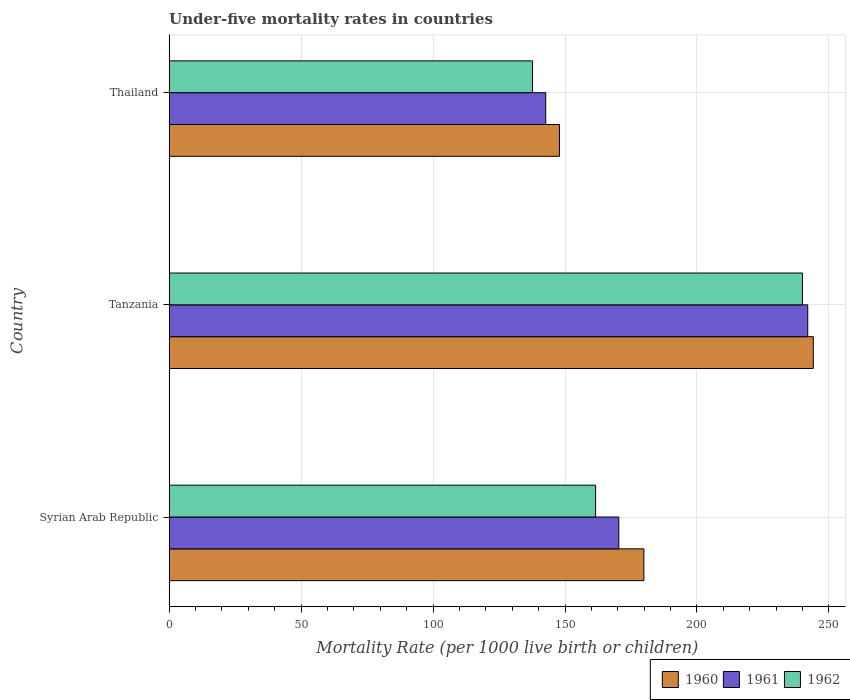Are the number of bars on each tick of the Y-axis equal?
Your answer should be very brief. Yes. How many bars are there on the 2nd tick from the top?
Offer a terse response. 3. How many bars are there on the 1st tick from the bottom?
Your answer should be very brief. 3. What is the label of the 2nd group of bars from the top?
Offer a very short reply. Tanzania. In how many cases, is the number of bars for a given country not equal to the number of legend labels?
Provide a succinct answer. 0. What is the under-five mortality rate in 1962 in Syrian Arab Republic?
Your answer should be compact. 161.6. Across all countries, what is the maximum under-five mortality rate in 1962?
Ensure brevity in your answer.  240. Across all countries, what is the minimum under-five mortality rate in 1962?
Make the answer very short. 137.7. In which country was the under-five mortality rate in 1961 maximum?
Provide a succinct answer. Tanzania. In which country was the under-five mortality rate in 1961 minimum?
Your answer should be compact. Thailand. What is the total under-five mortality rate in 1960 in the graph?
Your answer should be very brief. 571.9. What is the difference between the under-five mortality rate in 1962 in Thailand and the under-five mortality rate in 1961 in Tanzania?
Offer a terse response. -104.3. What is the average under-five mortality rate in 1961 per country?
Make the answer very short. 185.03. What is the difference between the under-five mortality rate in 1960 and under-five mortality rate in 1961 in Tanzania?
Provide a short and direct response. 2.1. What is the ratio of the under-five mortality rate in 1960 in Syrian Arab Republic to that in Thailand?
Your answer should be compact. 1.22. Is the difference between the under-five mortality rate in 1960 in Tanzania and Thailand greater than the difference between the under-five mortality rate in 1961 in Tanzania and Thailand?
Offer a terse response. No. What is the difference between the highest and the second highest under-five mortality rate in 1961?
Your response must be concise. 71.6. What is the difference between the highest and the lowest under-five mortality rate in 1960?
Your answer should be very brief. 96.2. Is the sum of the under-five mortality rate in 1962 in Syrian Arab Republic and Thailand greater than the maximum under-five mortality rate in 1960 across all countries?
Offer a very short reply. Yes. What does the 2nd bar from the top in Tanzania represents?
Your answer should be compact. 1961. Is it the case that in every country, the sum of the under-five mortality rate in 1960 and under-five mortality rate in 1962 is greater than the under-five mortality rate in 1961?
Make the answer very short. Yes. How many bars are there?
Give a very brief answer. 9. Are all the bars in the graph horizontal?
Provide a short and direct response. Yes. How many countries are there in the graph?
Give a very brief answer. 3. What is the difference between two consecutive major ticks on the X-axis?
Keep it short and to the point. 50. Does the graph contain grids?
Offer a terse response. Yes. Where does the legend appear in the graph?
Provide a short and direct response. Bottom right. How many legend labels are there?
Keep it short and to the point. 3. What is the title of the graph?
Your answer should be compact. Under-five mortality rates in countries. What is the label or title of the X-axis?
Your answer should be very brief. Mortality Rate (per 1000 live birth or children). What is the label or title of the Y-axis?
Your response must be concise. Country. What is the Mortality Rate (per 1000 live birth or children) of 1960 in Syrian Arab Republic?
Offer a terse response. 179.9. What is the Mortality Rate (per 1000 live birth or children) of 1961 in Syrian Arab Republic?
Make the answer very short. 170.4. What is the Mortality Rate (per 1000 live birth or children) of 1962 in Syrian Arab Republic?
Your answer should be compact. 161.6. What is the Mortality Rate (per 1000 live birth or children) of 1960 in Tanzania?
Your answer should be very brief. 244.1. What is the Mortality Rate (per 1000 live birth or children) of 1961 in Tanzania?
Ensure brevity in your answer.  242. What is the Mortality Rate (per 1000 live birth or children) in 1962 in Tanzania?
Offer a terse response. 240. What is the Mortality Rate (per 1000 live birth or children) of 1960 in Thailand?
Your response must be concise. 147.9. What is the Mortality Rate (per 1000 live birth or children) of 1961 in Thailand?
Offer a very short reply. 142.7. What is the Mortality Rate (per 1000 live birth or children) of 1962 in Thailand?
Offer a terse response. 137.7. Across all countries, what is the maximum Mortality Rate (per 1000 live birth or children) in 1960?
Your answer should be compact. 244.1. Across all countries, what is the maximum Mortality Rate (per 1000 live birth or children) in 1961?
Offer a terse response. 242. Across all countries, what is the maximum Mortality Rate (per 1000 live birth or children) in 1962?
Offer a very short reply. 240. Across all countries, what is the minimum Mortality Rate (per 1000 live birth or children) in 1960?
Ensure brevity in your answer.  147.9. Across all countries, what is the minimum Mortality Rate (per 1000 live birth or children) in 1961?
Ensure brevity in your answer.  142.7. Across all countries, what is the minimum Mortality Rate (per 1000 live birth or children) of 1962?
Provide a short and direct response. 137.7. What is the total Mortality Rate (per 1000 live birth or children) of 1960 in the graph?
Ensure brevity in your answer.  571.9. What is the total Mortality Rate (per 1000 live birth or children) in 1961 in the graph?
Your answer should be compact. 555.1. What is the total Mortality Rate (per 1000 live birth or children) in 1962 in the graph?
Your answer should be very brief. 539.3. What is the difference between the Mortality Rate (per 1000 live birth or children) of 1960 in Syrian Arab Republic and that in Tanzania?
Make the answer very short. -64.2. What is the difference between the Mortality Rate (per 1000 live birth or children) of 1961 in Syrian Arab Republic and that in Tanzania?
Give a very brief answer. -71.6. What is the difference between the Mortality Rate (per 1000 live birth or children) of 1962 in Syrian Arab Republic and that in Tanzania?
Give a very brief answer. -78.4. What is the difference between the Mortality Rate (per 1000 live birth or children) of 1961 in Syrian Arab Republic and that in Thailand?
Your response must be concise. 27.7. What is the difference between the Mortality Rate (per 1000 live birth or children) in 1962 in Syrian Arab Republic and that in Thailand?
Offer a very short reply. 23.9. What is the difference between the Mortality Rate (per 1000 live birth or children) of 1960 in Tanzania and that in Thailand?
Keep it short and to the point. 96.2. What is the difference between the Mortality Rate (per 1000 live birth or children) in 1961 in Tanzania and that in Thailand?
Your answer should be compact. 99.3. What is the difference between the Mortality Rate (per 1000 live birth or children) in 1962 in Tanzania and that in Thailand?
Provide a succinct answer. 102.3. What is the difference between the Mortality Rate (per 1000 live birth or children) in 1960 in Syrian Arab Republic and the Mortality Rate (per 1000 live birth or children) in 1961 in Tanzania?
Your response must be concise. -62.1. What is the difference between the Mortality Rate (per 1000 live birth or children) of 1960 in Syrian Arab Republic and the Mortality Rate (per 1000 live birth or children) of 1962 in Tanzania?
Make the answer very short. -60.1. What is the difference between the Mortality Rate (per 1000 live birth or children) in 1961 in Syrian Arab Republic and the Mortality Rate (per 1000 live birth or children) in 1962 in Tanzania?
Offer a very short reply. -69.6. What is the difference between the Mortality Rate (per 1000 live birth or children) in 1960 in Syrian Arab Republic and the Mortality Rate (per 1000 live birth or children) in 1961 in Thailand?
Provide a succinct answer. 37.2. What is the difference between the Mortality Rate (per 1000 live birth or children) in 1960 in Syrian Arab Republic and the Mortality Rate (per 1000 live birth or children) in 1962 in Thailand?
Your answer should be very brief. 42.2. What is the difference between the Mortality Rate (per 1000 live birth or children) in 1961 in Syrian Arab Republic and the Mortality Rate (per 1000 live birth or children) in 1962 in Thailand?
Give a very brief answer. 32.7. What is the difference between the Mortality Rate (per 1000 live birth or children) in 1960 in Tanzania and the Mortality Rate (per 1000 live birth or children) in 1961 in Thailand?
Give a very brief answer. 101.4. What is the difference between the Mortality Rate (per 1000 live birth or children) in 1960 in Tanzania and the Mortality Rate (per 1000 live birth or children) in 1962 in Thailand?
Keep it short and to the point. 106.4. What is the difference between the Mortality Rate (per 1000 live birth or children) in 1961 in Tanzania and the Mortality Rate (per 1000 live birth or children) in 1962 in Thailand?
Your answer should be very brief. 104.3. What is the average Mortality Rate (per 1000 live birth or children) of 1960 per country?
Ensure brevity in your answer.  190.63. What is the average Mortality Rate (per 1000 live birth or children) of 1961 per country?
Offer a very short reply. 185.03. What is the average Mortality Rate (per 1000 live birth or children) in 1962 per country?
Provide a short and direct response. 179.77. What is the difference between the Mortality Rate (per 1000 live birth or children) of 1961 and Mortality Rate (per 1000 live birth or children) of 1962 in Syrian Arab Republic?
Give a very brief answer. 8.8. What is the difference between the Mortality Rate (per 1000 live birth or children) of 1961 and Mortality Rate (per 1000 live birth or children) of 1962 in Thailand?
Ensure brevity in your answer.  5. What is the ratio of the Mortality Rate (per 1000 live birth or children) of 1960 in Syrian Arab Republic to that in Tanzania?
Offer a very short reply. 0.74. What is the ratio of the Mortality Rate (per 1000 live birth or children) of 1961 in Syrian Arab Republic to that in Tanzania?
Your response must be concise. 0.7. What is the ratio of the Mortality Rate (per 1000 live birth or children) of 1962 in Syrian Arab Republic to that in Tanzania?
Offer a terse response. 0.67. What is the ratio of the Mortality Rate (per 1000 live birth or children) in 1960 in Syrian Arab Republic to that in Thailand?
Provide a succinct answer. 1.22. What is the ratio of the Mortality Rate (per 1000 live birth or children) in 1961 in Syrian Arab Republic to that in Thailand?
Offer a very short reply. 1.19. What is the ratio of the Mortality Rate (per 1000 live birth or children) in 1962 in Syrian Arab Republic to that in Thailand?
Ensure brevity in your answer.  1.17. What is the ratio of the Mortality Rate (per 1000 live birth or children) in 1960 in Tanzania to that in Thailand?
Offer a very short reply. 1.65. What is the ratio of the Mortality Rate (per 1000 live birth or children) of 1961 in Tanzania to that in Thailand?
Provide a succinct answer. 1.7. What is the ratio of the Mortality Rate (per 1000 live birth or children) in 1962 in Tanzania to that in Thailand?
Ensure brevity in your answer.  1.74. What is the difference between the highest and the second highest Mortality Rate (per 1000 live birth or children) in 1960?
Provide a short and direct response. 64.2. What is the difference between the highest and the second highest Mortality Rate (per 1000 live birth or children) of 1961?
Make the answer very short. 71.6. What is the difference between the highest and the second highest Mortality Rate (per 1000 live birth or children) of 1962?
Ensure brevity in your answer.  78.4. What is the difference between the highest and the lowest Mortality Rate (per 1000 live birth or children) in 1960?
Give a very brief answer. 96.2. What is the difference between the highest and the lowest Mortality Rate (per 1000 live birth or children) of 1961?
Offer a terse response. 99.3. What is the difference between the highest and the lowest Mortality Rate (per 1000 live birth or children) in 1962?
Provide a short and direct response. 102.3. 